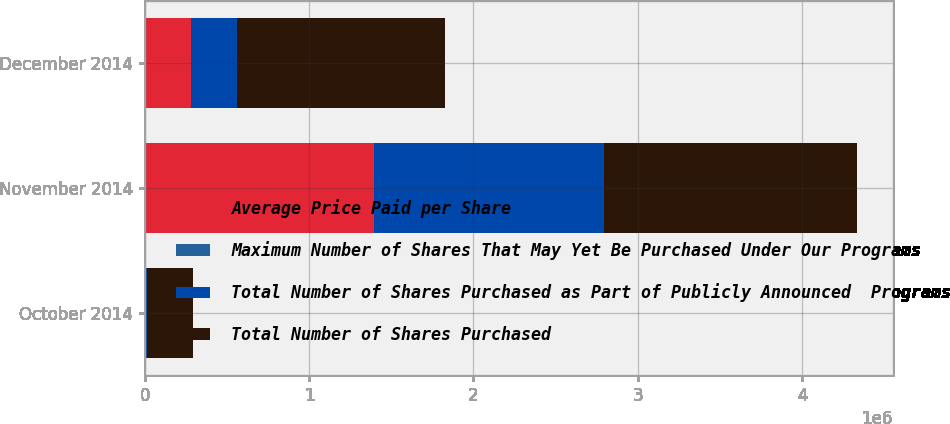<chart> <loc_0><loc_0><loc_500><loc_500><stacked_bar_chart><ecel><fcel>October 2014<fcel>November 2014<fcel>December 2014<nl><fcel>Average Price Paid per Share<fcel>7862<fcel>1.39573e+06<fcel>279982<nl><fcel>Maximum Number of Shares That May Yet Be Purchased Under Our Programs<fcel>297.72<fcel>314.38<fcel>305.98<nl><fcel>Total Number of Shares Purchased as Part of Publicly Announced  Programs<fcel>7771<fcel>1.39573e+06<fcel>279982<nl><fcel>Total Number of Shares Purchased<fcel>279982<fcel>1.54414e+06<fcel>1.26416e+06<nl></chart> 